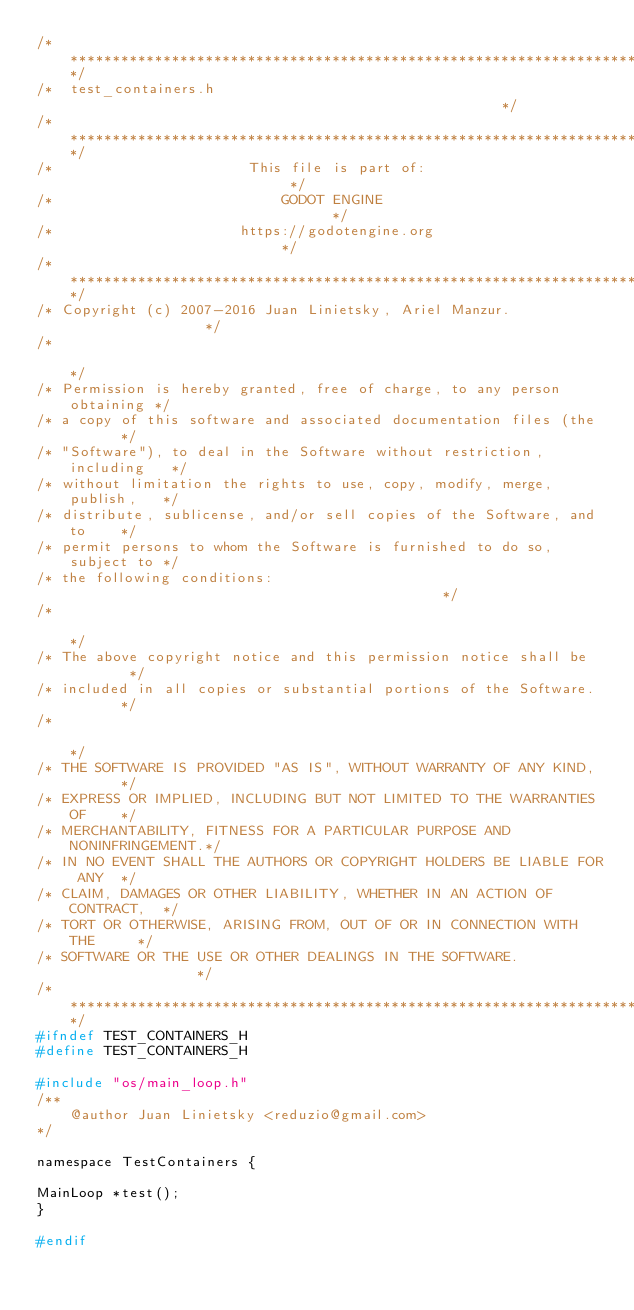<code> <loc_0><loc_0><loc_500><loc_500><_C_>/*************************************************************************/
/*  test_containers.h                                                    */
/*************************************************************************/
/*                       This file is part of:                           */
/*                           GODOT ENGINE                                */
/*                      https://godotengine.org                          */
/*************************************************************************/
/* Copyright (c) 2007-2016 Juan Linietsky, Ariel Manzur.                 */
/*                                                                       */
/* Permission is hereby granted, free of charge, to any person obtaining */
/* a copy of this software and associated documentation files (the       */
/* "Software"), to deal in the Software without restriction, including   */
/* without limitation the rights to use, copy, modify, merge, publish,   */
/* distribute, sublicense, and/or sell copies of the Software, and to    */
/* permit persons to whom the Software is furnished to do so, subject to */
/* the following conditions:                                             */
/*                                                                       */
/* The above copyright notice and this permission notice shall be        */
/* included in all copies or substantial portions of the Software.       */
/*                                                                       */
/* THE SOFTWARE IS PROVIDED "AS IS", WITHOUT WARRANTY OF ANY KIND,       */
/* EXPRESS OR IMPLIED, INCLUDING BUT NOT LIMITED TO THE WARRANTIES OF    */
/* MERCHANTABILITY, FITNESS FOR A PARTICULAR PURPOSE AND NONINFRINGEMENT.*/
/* IN NO EVENT SHALL THE AUTHORS OR COPYRIGHT HOLDERS BE LIABLE FOR ANY  */
/* CLAIM, DAMAGES OR OTHER LIABILITY, WHETHER IN AN ACTION OF CONTRACT,  */
/* TORT OR OTHERWISE, ARISING FROM, OUT OF OR IN CONNECTION WITH THE     */
/* SOFTWARE OR THE USE OR OTHER DEALINGS IN THE SOFTWARE.                */
/*************************************************************************/
#ifndef TEST_CONTAINERS_H
#define TEST_CONTAINERS_H

#include "os/main_loop.h"
/**
	@author Juan Linietsky <reduzio@gmail.com>
*/

namespace TestContainers {

MainLoop *test();
}

#endif
</code> 